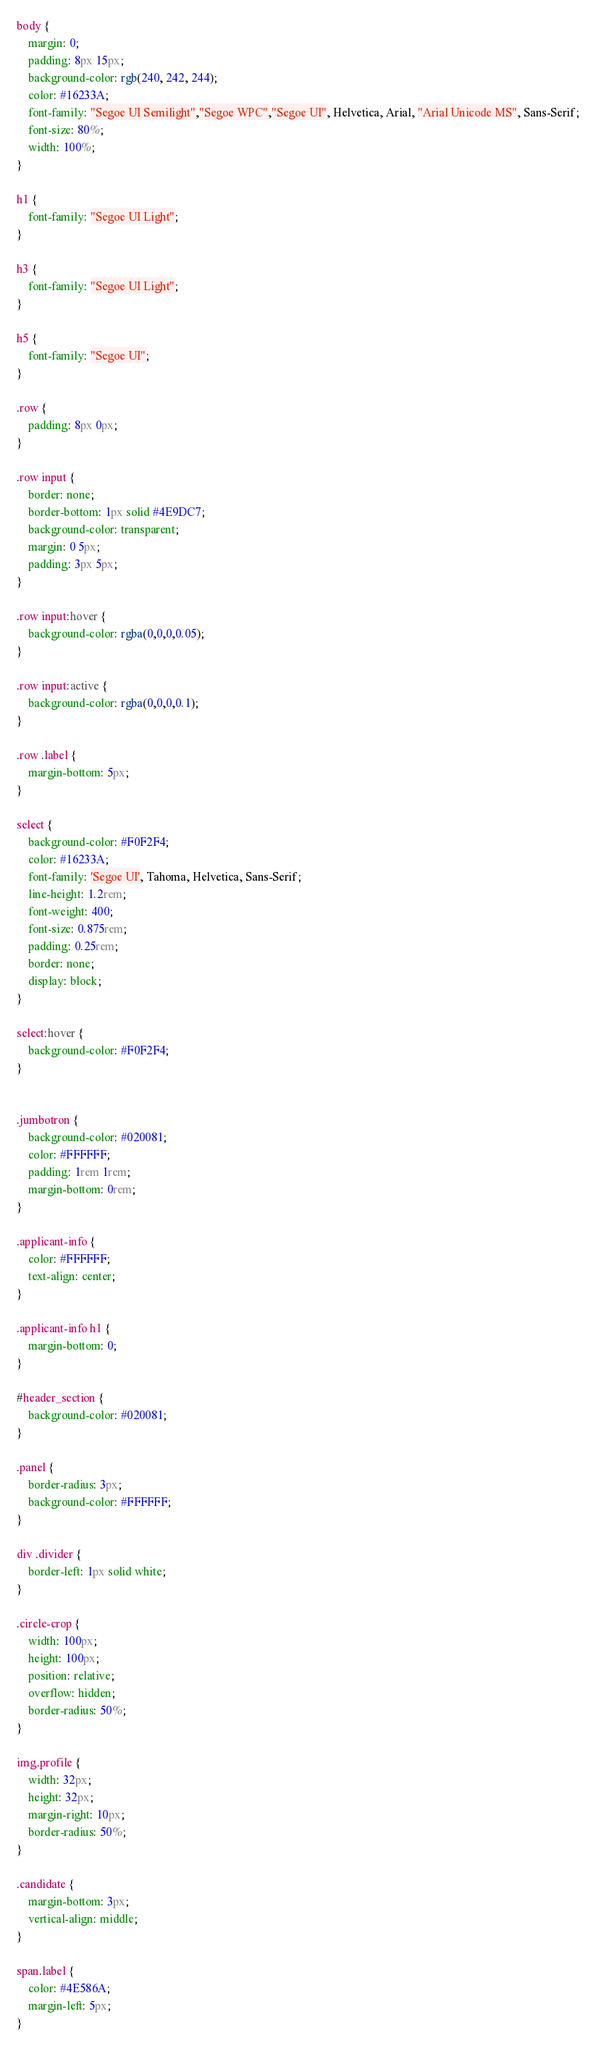<code> <loc_0><loc_0><loc_500><loc_500><_CSS_>body {
	margin: 0;
	padding: 8px 15px;
	background-color: rgb(240, 242, 244);
	color: #16233A;
	font-family: "Segoe UI Semilight","Segoe WPC","Segoe UI", Helvetica, Arial, "Arial Unicode MS", Sans-Serif;
	font-size: 80%;
	width: 100%;
}

h1 {
	font-family: "Segoe UI Light";
}

h3 {
	font-family: "Segoe UI Light";
}

h5 {
	font-family: "Segoe UI";
}

.row {
	padding: 8px 0px;
}

.row input {
	border: none;
	border-bottom: 1px solid #4E9DC7;
	background-color: transparent;
	margin: 0 5px;
	padding: 3px 5px;
}

.row input:hover {
	background-color: rgba(0,0,0,0.05);
}

.row input:active {
	background-color: rgba(0,0,0,0.1);
}

.row .label {
	margin-bottom: 5px;
}

select {
	background-color: #F0F2F4;
	color: #16233A;
	font-family: 'Segoe UI', Tahoma, Helvetica, Sans-Serif;
	line-height: 1.2rem;
	font-weight: 400;
	font-size: 0.875rem;
	padding: 0.25rem;
	border: none;
	display: block;
}

select:hover {
	background-color: #F0F2F4;
}


.jumbotron {
	background-color: #020081;
	color: #FFFFFF;
	padding: 1rem 1rem;
	margin-bottom: 0rem;
}

.applicant-info {
	color: #FFFFFF;
	text-align: center;
}

.applicant-info h1 {
	margin-bottom: 0;
}

#header_section {
	background-color: #020081;
}

.panel {
	border-radius: 3px;
	background-color: #FFFFFF;
}

div .divider {
	border-left: 1px solid white;
}

.circle-crop {
	width: 100px;
	height: 100px;
	position: relative;
	overflow: hidden;
	border-radius: 50%;
}

img.profile {
	width: 32px;
	height: 32px;
	margin-right: 10px;
	border-radius: 50%;
}

.candidate {
	margin-bottom: 3px;
	vertical-align: middle;
}

span.label {
	color: #4E586A;
	margin-left: 5px;
}
</code> 